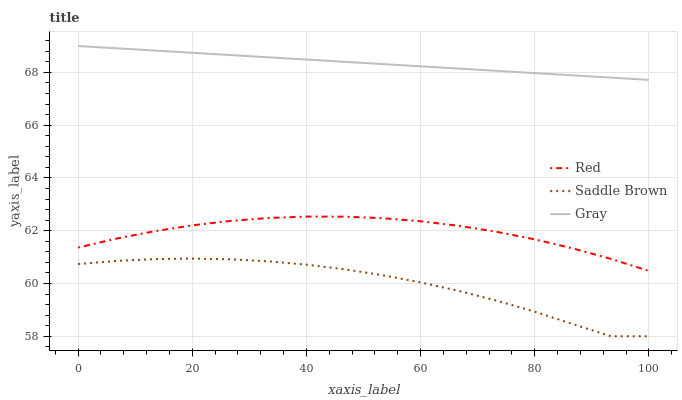Does Saddle Brown have the minimum area under the curve?
Answer yes or no. Yes. Does Gray have the maximum area under the curve?
Answer yes or no. Yes. Does Red have the minimum area under the curve?
Answer yes or no. No. Does Red have the maximum area under the curve?
Answer yes or no. No. Is Gray the smoothest?
Answer yes or no. Yes. Is Saddle Brown the roughest?
Answer yes or no. Yes. Is Red the smoothest?
Answer yes or no. No. Is Red the roughest?
Answer yes or no. No. Does Saddle Brown have the lowest value?
Answer yes or no. Yes. Does Red have the lowest value?
Answer yes or no. No. Does Gray have the highest value?
Answer yes or no. Yes. Does Red have the highest value?
Answer yes or no. No. Is Saddle Brown less than Gray?
Answer yes or no. Yes. Is Gray greater than Red?
Answer yes or no. Yes. Does Saddle Brown intersect Gray?
Answer yes or no. No. 